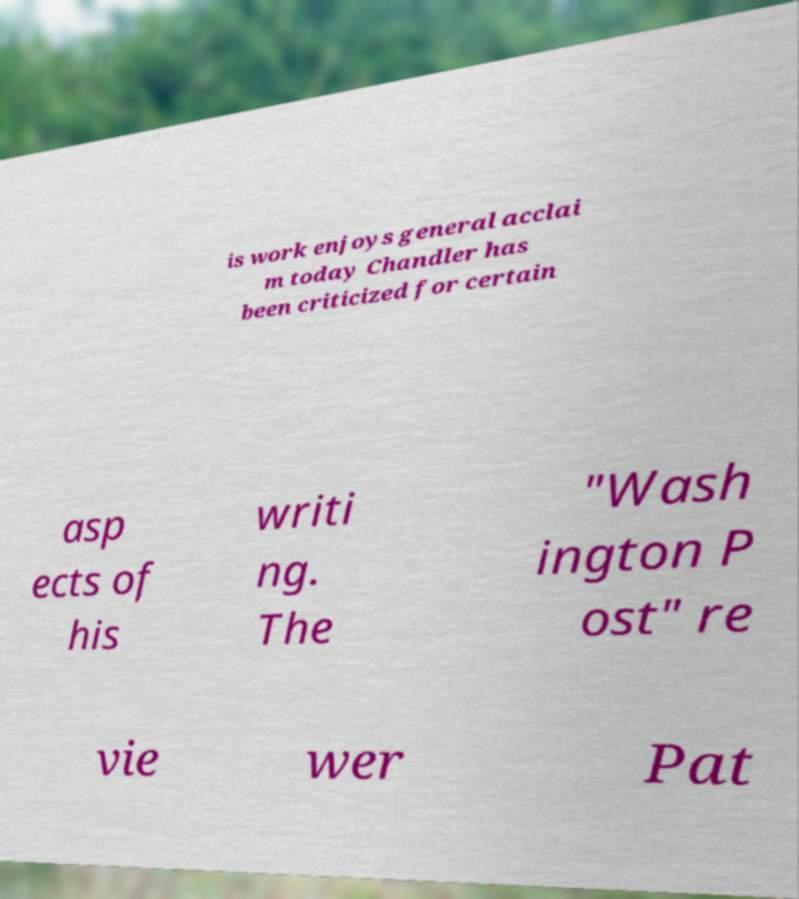What messages or text are displayed in this image? I need them in a readable, typed format. is work enjoys general acclai m today Chandler has been criticized for certain asp ects of his writi ng. The "Wash ington P ost" re vie wer Pat 